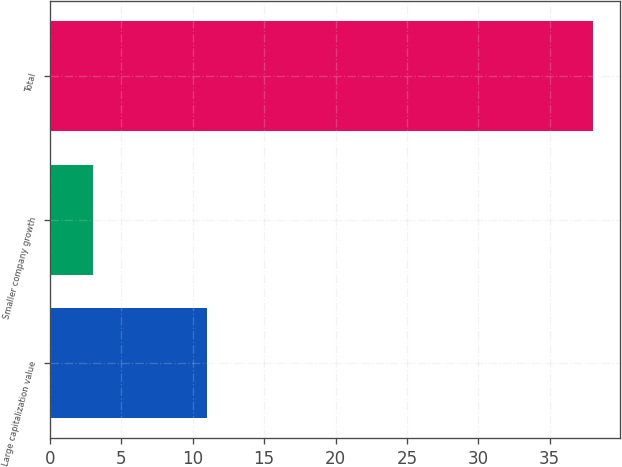Convert chart. <chart><loc_0><loc_0><loc_500><loc_500><bar_chart><fcel>Large capitalization value<fcel>Smaller company growth<fcel>Total<nl><fcel>11<fcel>3<fcel>38<nl></chart> 